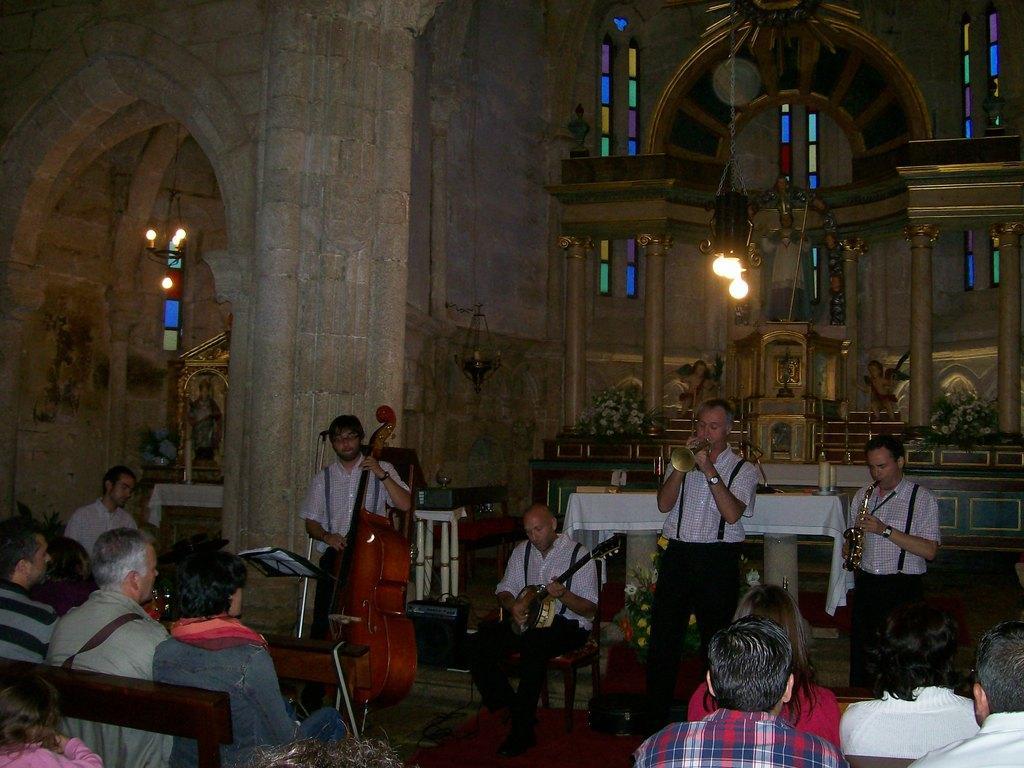Please provide a concise description of this image. There is a music band here in which four of them were playing four different musical instruments in their hands. There are some people sitting on the benches and watching them. In the background there is a light and some idols here. We can observe a wall here. 